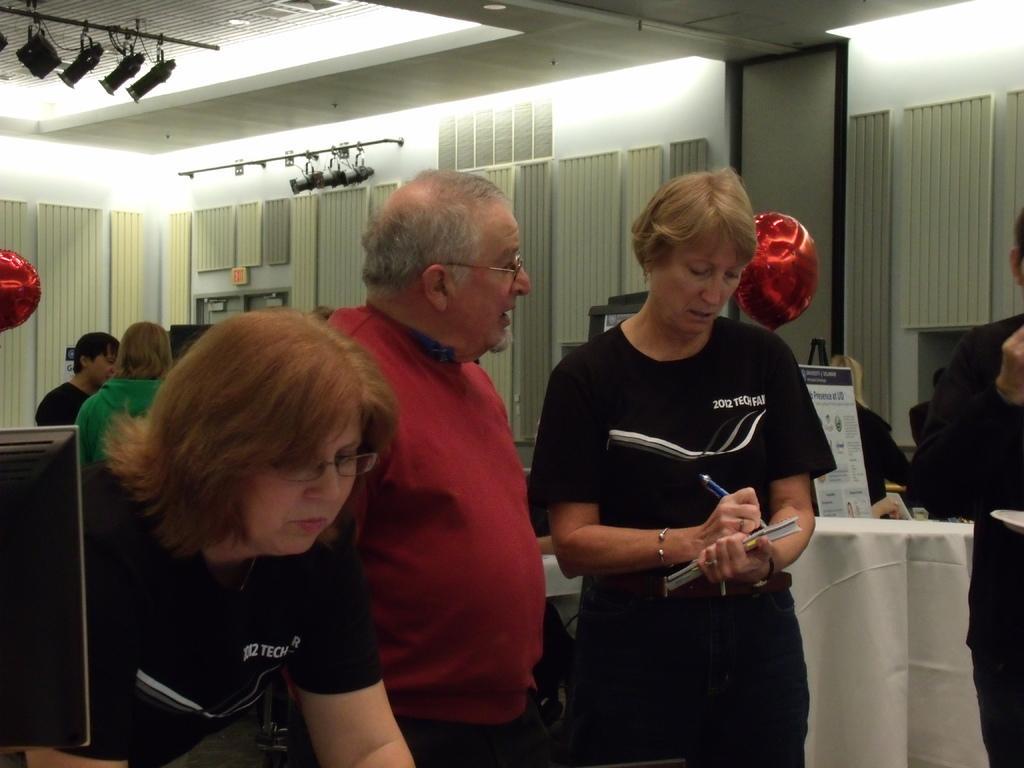How would you summarize this image in a sentence or two? In this image we can see many people. Few people are wearing specs. There is a lady holding book and writing with a pen. Also we can see balloons. On the left side there is a monitor. In the back we can see curtains. Also we can see lights and few other things. 